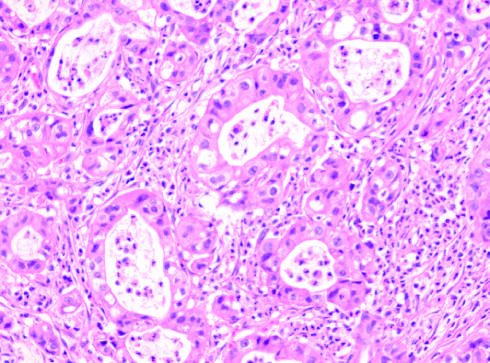what has the same appearance as that of intrahepatic cholangiocarcinoma?
Answer the question using a single word or phrase. The tumor 